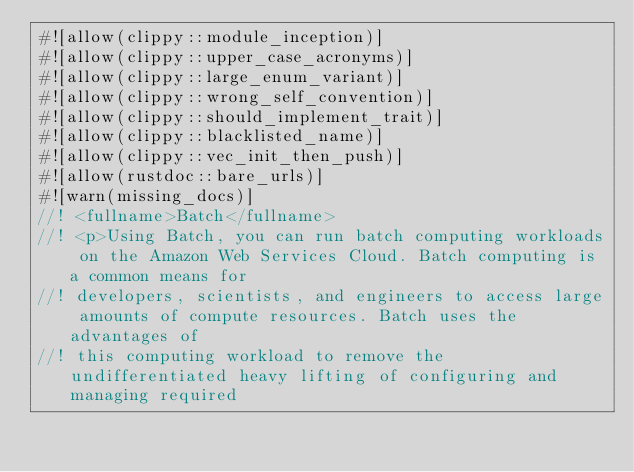Convert code to text. <code><loc_0><loc_0><loc_500><loc_500><_Rust_>#![allow(clippy::module_inception)]
#![allow(clippy::upper_case_acronyms)]
#![allow(clippy::large_enum_variant)]
#![allow(clippy::wrong_self_convention)]
#![allow(clippy::should_implement_trait)]
#![allow(clippy::blacklisted_name)]
#![allow(clippy::vec_init_then_push)]
#![allow(rustdoc::bare_urls)]
#![warn(missing_docs)]
//! <fullname>Batch</fullname>
//! <p>Using Batch, you can run batch computing workloads on the Amazon Web Services Cloud. Batch computing is a common means for
//! developers, scientists, and engineers to access large amounts of compute resources. Batch uses the advantages of
//! this computing workload to remove the undifferentiated heavy lifting of configuring and managing required</code> 